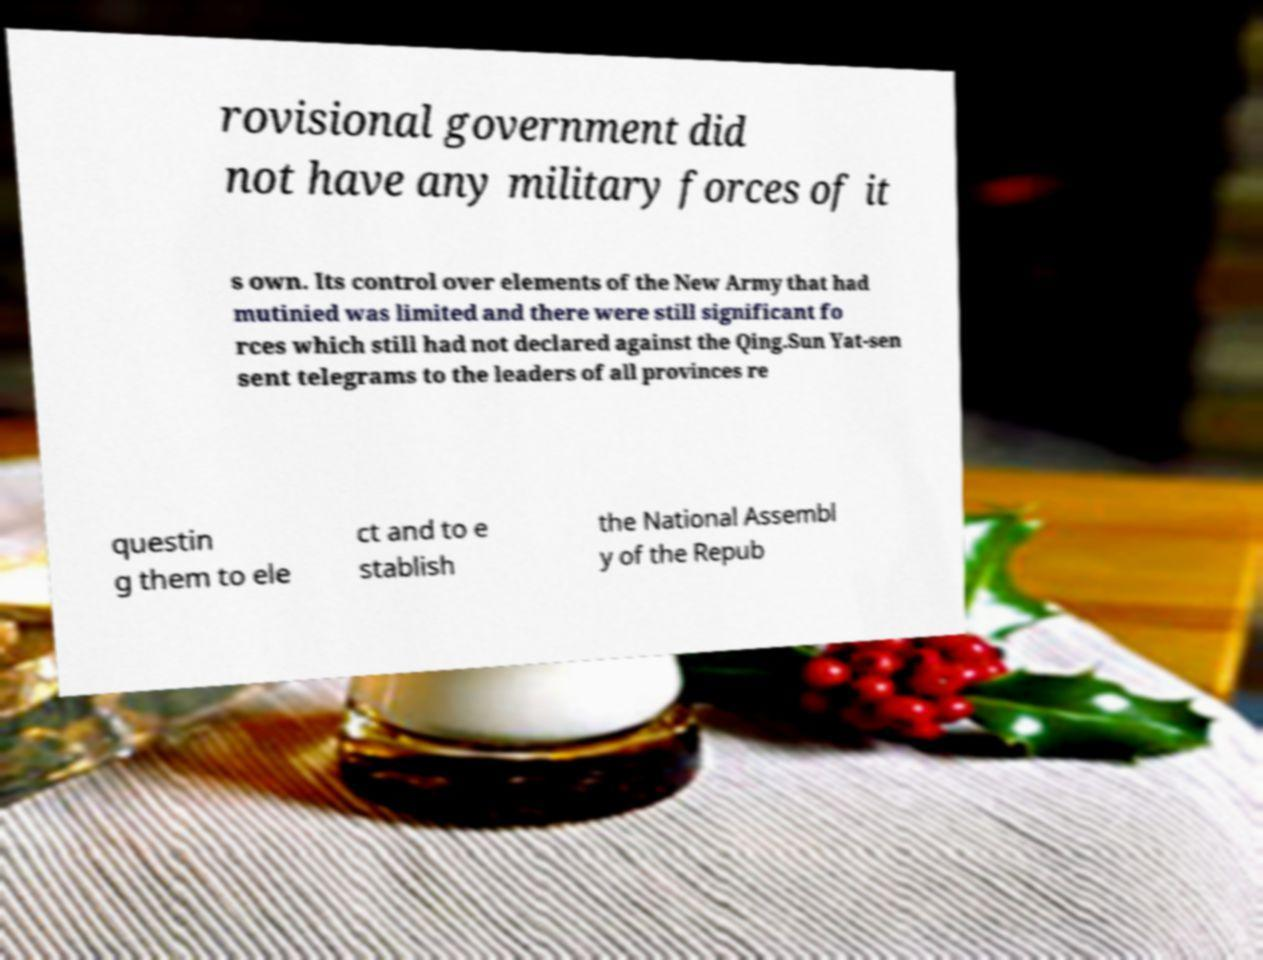I need the written content from this picture converted into text. Can you do that? rovisional government did not have any military forces of it s own. Its control over elements of the New Army that had mutinied was limited and there were still significant fo rces which still had not declared against the Qing.Sun Yat-sen sent telegrams to the leaders of all provinces re questin g them to ele ct and to e stablish the National Assembl y of the Repub 